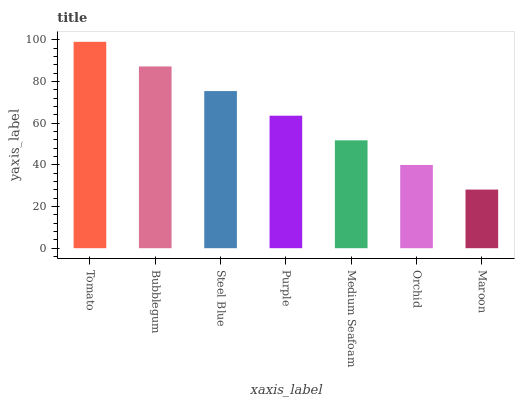Is Bubblegum the minimum?
Answer yes or no. No. Is Bubblegum the maximum?
Answer yes or no. No. Is Tomato greater than Bubblegum?
Answer yes or no. Yes. Is Bubblegum less than Tomato?
Answer yes or no. Yes. Is Bubblegum greater than Tomato?
Answer yes or no. No. Is Tomato less than Bubblegum?
Answer yes or no. No. Is Purple the high median?
Answer yes or no. Yes. Is Purple the low median?
Answer yes or no. Yes. Is Bubblegum the high median?
Answer yes or no. No. Is Orchid the low median?
Answer yes or no. No. 